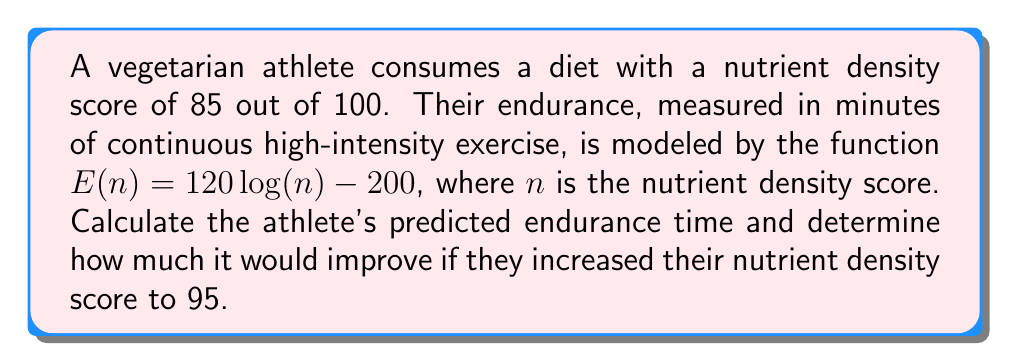Can you solve this math problem? 1. Given:
   - Current nutrient density score: $n_1 = 85$
   - Endurance function: $E(n) = 120 \log(n) - 200$
   - Target nutrient density score: $n_2 = 95$

2. Calculate current endurance time:
   $E(85) = 120 \log(85) - 200$
   $= 120 \cdot 4.44265 - 200$
   $= 533.118 - 200$
   $= 333.118$ minutes

3. Calculate endurance time with improved nutrient density:
   $E(95) = 120 \log(95) - 200$
   $= 120 \cdot 4.55388 - 200$
   $= 546.4656 - 200$
   $= 346.4656$ minutes

4. Calculate the improvement:
   Improvement = $E(95) - E(85)$
   $= 346.4656 - 333.118$
   $= 13.3476$ minutes
Answer: 13.35 minutes 